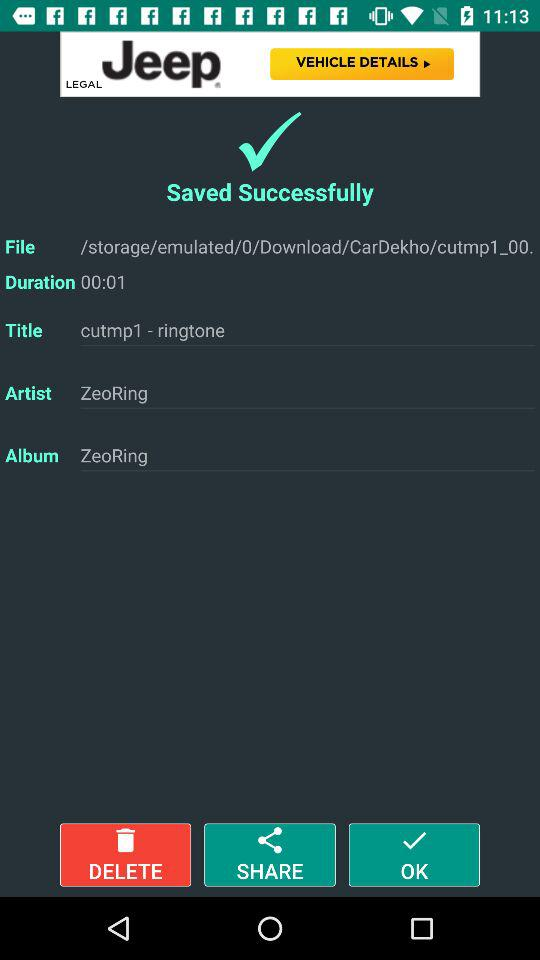What might 'cutmp1 - ringtone' indicate? The 'cutmp1 - ringtone' seems to be the title of a music file, most likely a customized ringtone. The prefix 'cutmp1' suggests that this might be the first in what could be a series of audio cuts or versions, while 'ringtone' clearly states its intended use. 